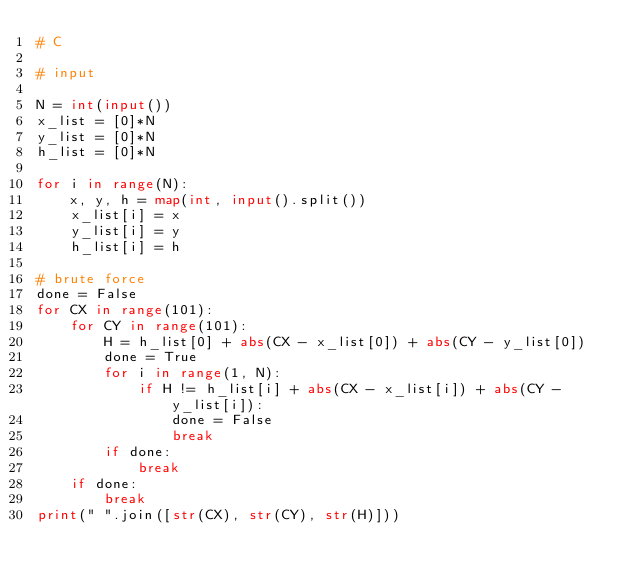Convert code to text. <code><loc_0><loc_0><loc_500><loc_500><_Python_># C

# input

N = int(input())
x_list = [0]*N
y_list = [0]*N
h_list = [0]*N

for i in range(N):
    x, y, h = map(int, input().split())
    x_list[i] = x
    y_list[i] = y
    h_list[i] = h
    
# brute force
done = False
for CX in range(101):
    for CY in range(101):
        H = h_list[0] + abs(CX - x_list[0]) + abs(CY - y_list[0])
        done = True
        for i in range(1, N):
            if H != h_list[i] + abs(CX - x_list[i]) + abs(CY - y_list[i]):
                done = False
                break
        if done:
            break
    if done:
        break
print(" ".join([str(CX), str(CY), str(H)]))</code> 